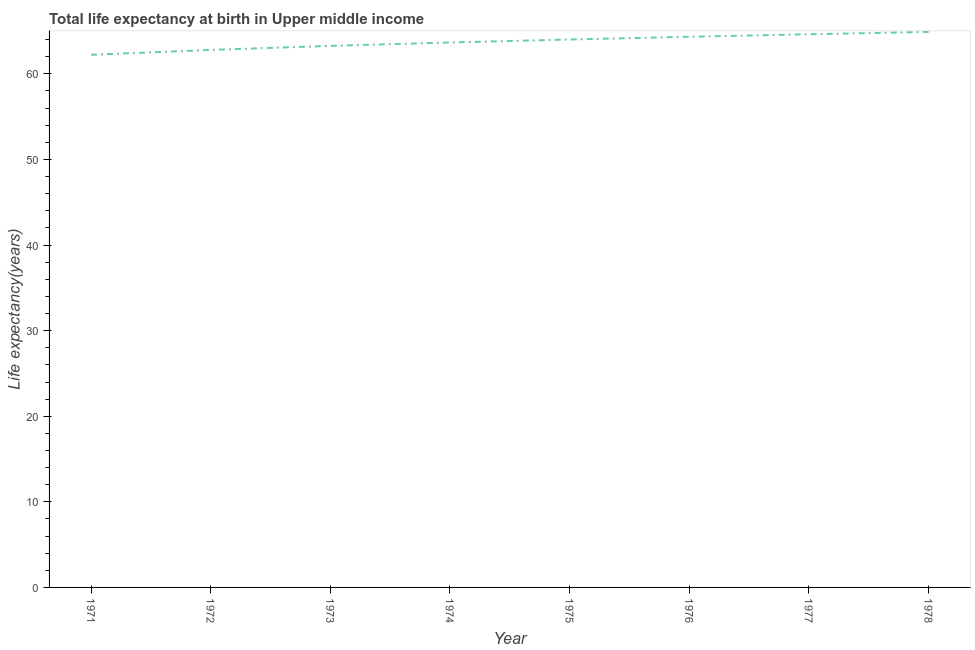What is the life expectancy at birth in 1972?
Give a very brief answer. 62.8. Across all years, what is the maximum life expectancy at birth?
Your answer should be very brief. 64.9. Across all years, what is the minimum life expectancy at birth?
Keep it short and to the point. 62.23. In which year was the life expectancy at birth maximum?
Offer a very short reply. 1978. In which year was the life expectancy at birth minimum?
Give a very brief answer. 1971. What is the sum of the life expectancy at birth?
Make the answer very short. 509.84. What is the difference between the life expectancy at birth in 1972 and 1975?
Provide a succinct answer. -1.21. What is the average life expectancy at birth per year?
Offer a terse response. 63.73. What is the median life expectancy at birth?
Your answer should be very brief. 63.84. In how many years, is the life expectancy at birth greater than 16 years?
Your response must be concise. 8. Do a majority of the years between 1971 and 1976 (inclusive) have life expectancy at birth greater than 32 years?
Offer a terse response. Yes. What is the ratio of the life expectancy at birth in 1974 to that in 1977?
Make the answer very short. 0.99. Is the difference between the life expectancy at birth in 1972 and 1973 greater than the difference between any two years?
Offer a very short reply. No. What is the difference between the highest and the second highest life expectancy at birth?
Provide a short and direct response. 0.27. What is the difference between the highest and the lowest life expectancy at birth?
Offer a very short reply. 2.67. In how many years, is the life expectancy at birth greater than the average life expectancy at birth taken over all years?
Give a very brief answer. 4. How many lines are there?
Offer a very short reply. 1. How many years are there in the graph?
Keep it short and to the point. 8. Does the graph contain any zero values?
Ensure brevity in your answer.  No. Does the graph contain grids?
Offer a terse response. No. What is the title of the graph?
Provide a succinct answer. Total life expectancy at birth in Upper middle income. What is the label or title of the Y-axis?
Offer a terse response. Life expectancy(years). What is the Life expectancy(years) in 1971?
Provide a succinct answer. 62.23. What is the Life expectancy(years) in 1972?
Give a very brief answer. 62.8. What is the Life expectancy(years) of 1973?
Provide a succinct answer. 63.27. What is the Life expectancy(years) in 1974?
Make the answer very short. 63.67. What is the Life expectancy(years) of 1975?
Your response must be concise. 64.01. What is the Life expectancy(years) in 1976?
Your answer should be very brief. 64.34. What is the Life expectancy(years) of 1977?
Provide a succinct answer. 64.63. What is the Life expectancy(years) in 1978?
Provide a succinct answer. 64.9. What is the difference between the Life expectancy(years) in 1971 and 1972?
Give a very brief answer. -0.57. What is the difference between the Life expectancy(years) in 1971 and 1973?
Offer a very short reply. -1.04. What is the difference between the Life expectancy(years) in 1971 and 1974?
Provide a succinct answer. -1.44. What is the difference between the Life expectancy(years) in 1971 and 1975?
Your answer should be very brief. -1.79. What is the difference between the Life expectancy(years) in 1971 and 1976?
Ensure brevity in your answer.  -2.11. What is the difference between the Life expectancy(years) in 1971 and 1977?
Ensure brevity in your answer.  -2.4. What is the difference between the Life expectancy(years) in 1971 and 1978?
Give a very brief answer. -2.67. What is the difference between the Life expectancy(years) in 1972 and 1973?
Your answer should be very brief. -0.47. What is the difference between the Life expectancy(years) in 1972 and 1974?
Offer a terse response. -0.87. What is the difference between the Life expectancy(years) in 1972 and 1975?
Provide a succinct answer. -1.21. What is the difference between the Life expectancy(years) in 1972 and 1976?
Offer a very short reply. -1.54. What is the difference between the Life expectancy(years) in 1972 and 1977?
Your response must be concise. -1.83. What is the difference between the Life expectancy(years) in 1972 and 1978?
Keep it short and to the point. -2.1. What is the difference between the Life expectancy(years) in 1973 and 1974?
Keep it short and to the point. -0.4. What is the difference between the Life expectancy(years) in 1973 and 1975?
Offer a very short reply. -0.74. What is the difference between the Life expectancy(years) in 1973 and 1976?
Your answer should be compact. -1.06. What is the difference between the Life expectancy(years) in 1973 and 1977?
Your response must be concise. -1.35. What is the difference between the Life expectancy(years) in 1973 and 1978?
Ensure brevity in your answer.  -1.62. What is the difference between the Life expectancy(years) in 1974 and 1975?
Your answer should be very brief. -0.35. What is the difference between the Life expectancy(years) in 1974 and 1976?
Provide a succinct answer. -0.67. What is the difference between the Life expectancy(years) in 1974 and 1977?
Provide a succinct answer. -0.96. What is the difference between the Life expectancy(years) in 1974 and 1978?
Provide a succinct answer. -1.23. What is the difference between the Life expectancy(years) in 1975 and 1976?
Keep it short and to the point. -0.32. What is the difference between the Life expectancy(years) in 1975 and 1977?
Offer a terse response. -0.61. What is the difference between the Life expectancy(years) in 1975 and 1978?
Ensure brevity in your answer.  -0.88. What is the difference between the Life expectancy(years) in 1976 and 1977?
Keep it short and to the point. -0.29. What is the difference between the Life expectancy(years) in 1976 and 1978?
Provide a succinct answer. -0.56. What is the difference between the Life expectancy(years) in 1977 and 1978?
Keep it short and to the point. -0.27. What is the ratio of the Life expectancy(years) in 1971 to that in 1972?
Provide a short and direct response. 0.99. What is the ratio of the Life expectancy(years) in 1971 to that in 1973?
Ensure brevity in your answer.  0.98. What is the ratio of the Life expectancy(years) in 1971 to that in 1974?
Offer a terse response. 0.98. What is the ratio of the Life expectancy(years) in 1971 to that in 1978?
Offer a terse response. 0.96. What is the ratio of the Life expectancy(years) in 1973 to that in 1976?
Your response must be concise. 0.98. What is the ratio of the Life expectancy(years) in 1974 to that in 1977?
Offer a very short reply. 0.98. What is the ratio of the Life expectancy(years) in 1975 to that in 1978?
Provide a succinct answer. 0.99. What is the ratio of the Life expectancy(years) in 1976 to that in 1977?
Provide a succinct answer. 1. 